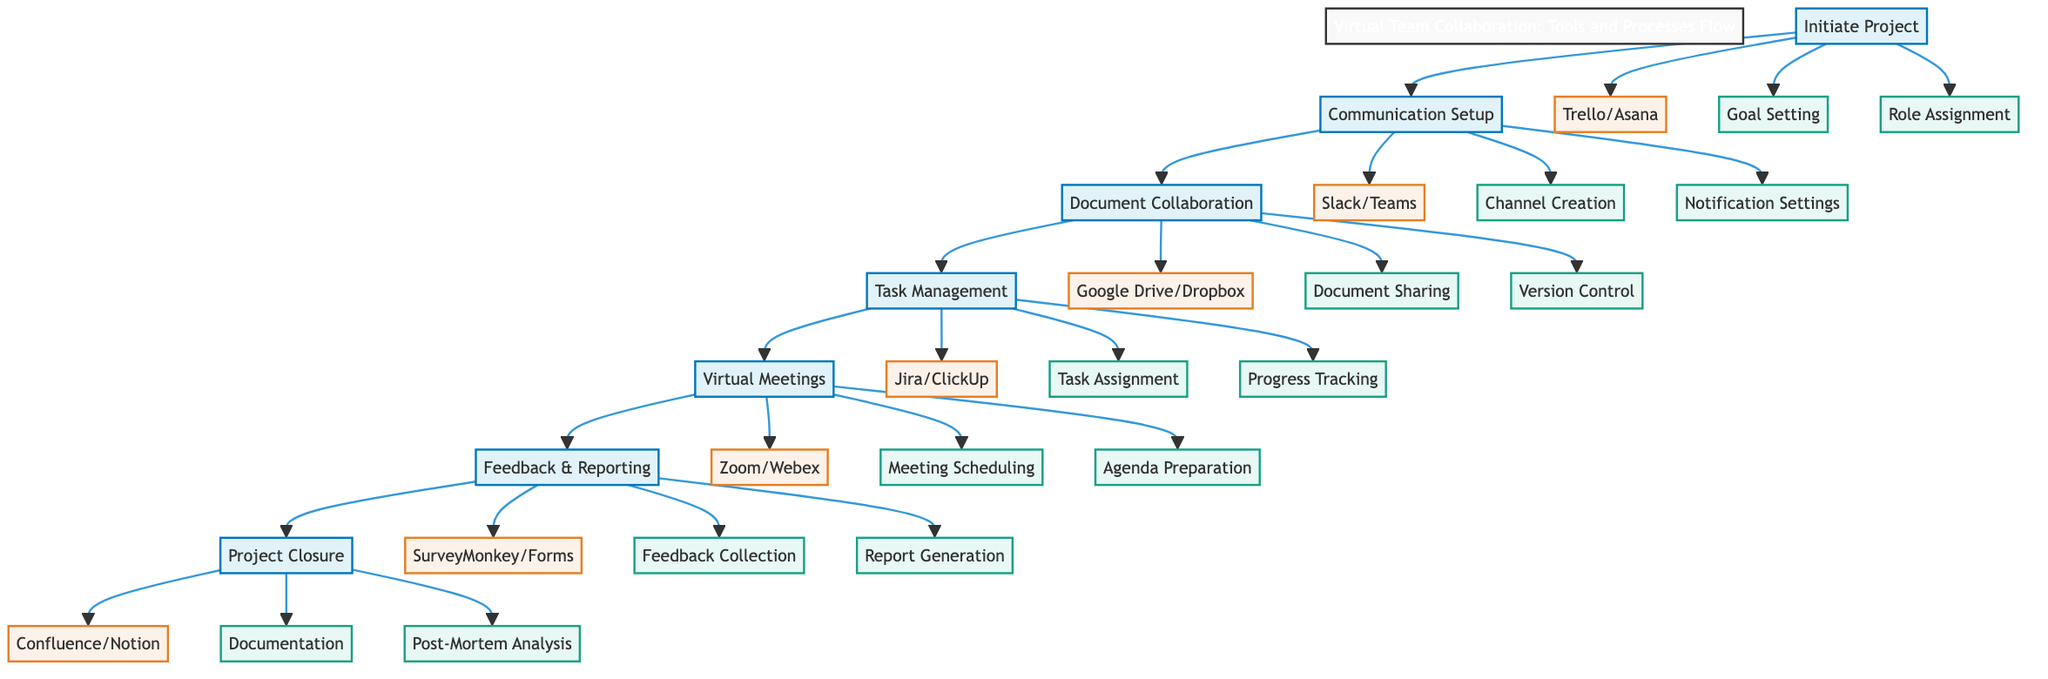What is the first step in the flow? The first step in the flow is indicated at the top of the diagram, labeled as "Initiate Project". This is the starting point where all subsequent steps originate.
Answer: Initiate Project How many tools are associated with "Document Collaboration"? By examining the "Document Collaboration" step in the diagram, it shows two tools listed below it: "Google Drive" and "Dropbox". Therefore, there are two tools related to this step.
Answer: 2 Which tool is used for "Task Management"? Looking at the "Task Management" step, the tools listed are "Jira" and "ClickUp". Therefore, one of the tools used for this task management process can be any of these two.
Answer: Jira or ClickUp What are the processes under the "Feedback & Reporting" step? The "Feedback & Reporting" step includes three processes: "Feedback Collection", "Report Generation", and another process that is clearly labeled. Thus, reviewing this section leads to mentioning all three.
Answer: Feedback Collection, Report Generation Which step follows "Virtual Meetings"? In the linear flow depicted in the diagram, the step that directly follows "Virtual Meetings" is "Feedback & Reporting". This indicates the sequential flow of activities within the virtual collaboration process.
Answer: Feedback & Reporting How many total steps are there in the diagram? Counting all the steps from beginning to end, the diagram shows seven distinct steps in total, beginning with "Initiate Project" and concluding with "Project Closure".
Answer: 7 What are the tools used in the "Communication Setup"? Under the "Communication Setup" step, there are two tools listed: "Slack" and "Microsoft Teams". This showcases the communication channels selected for the project.
Answer: Slack, Microsoft Teams Which processes are related to "Virtual Meetings"? The "Virtual Meetings" step identifies three related processes: "Meeting Scheduling", "Agenda Preparation", and another process. Therefore, all these processes contribute to organizing effective virtual meetings.
Answer: Meeting Scheduling, Agenda Preparation What concludes the project lifecycle in this diagram? The final step in the project lifecycle, as indicated at the bottom of the diagram's flow, is "Project Closure". This step summarizes the completion of all project activities and documentation.
Answer: Project Closure 